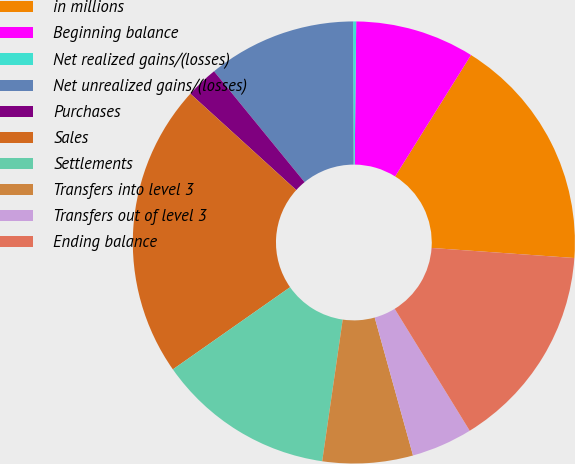Convert chart. <chart><loc_0><loc_0><loc_500><loc_500><pie_chart><fcel>in millions<fcel>Beginning balance<fcel>Net realized gains/(losses)<fcel>Net unrealized gains/(losses)<fcel>Purchases<fcel>Sales<fcel>Settlements<fcel>Transfers into level 3<fcel>Transfers out of level 3<fcel>Ending balance<nl><fcel>17.23%<fcel>8.72%<fcel>0.22%<fcel>10.85%<fcel>2.35%<fcel>21.48%<fcel>12.98%<fcel>6.6%<fcel>4.47%<fcel>15.1%<nl></chart> 